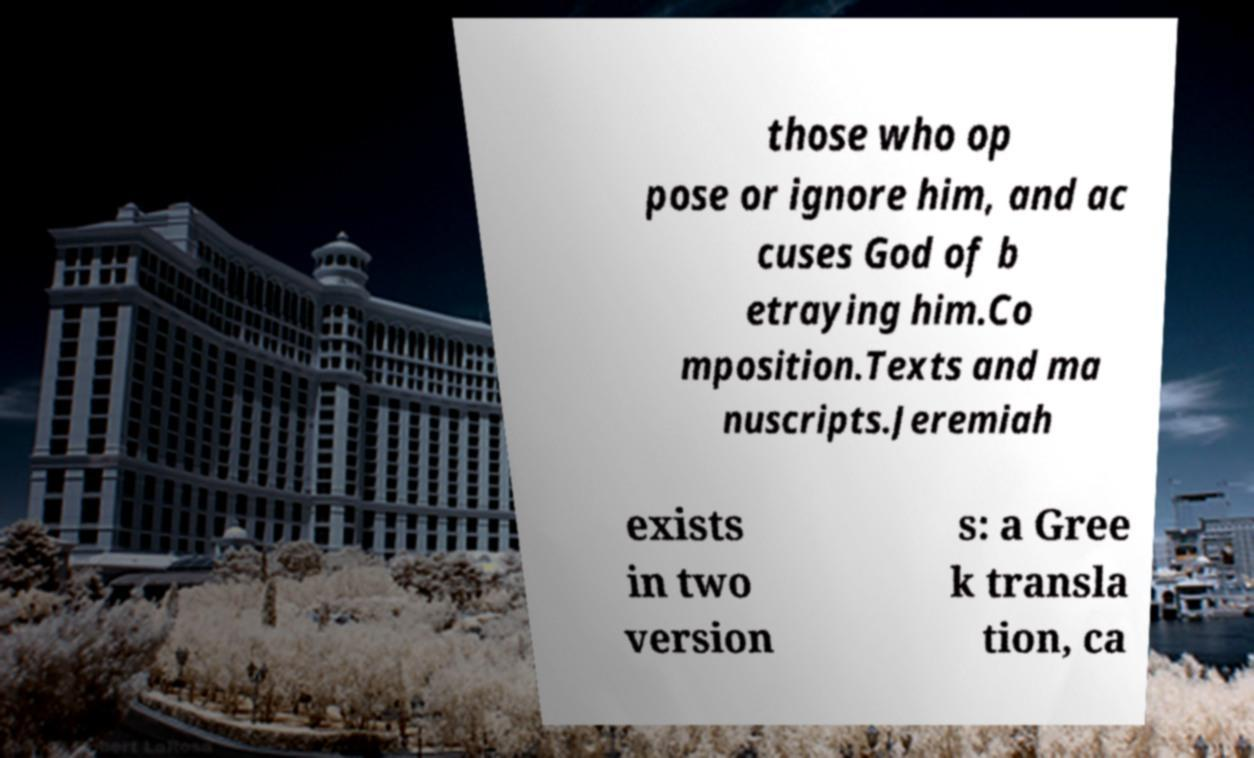Can you accurately transcribe the text from the provided image for me? those who op pose or ignore him, and ac cuses God of b etraying him.Co mposition.Texts and ma nuscripts.Jeremiah exists in two version s: a Gree k transla tion, ca 